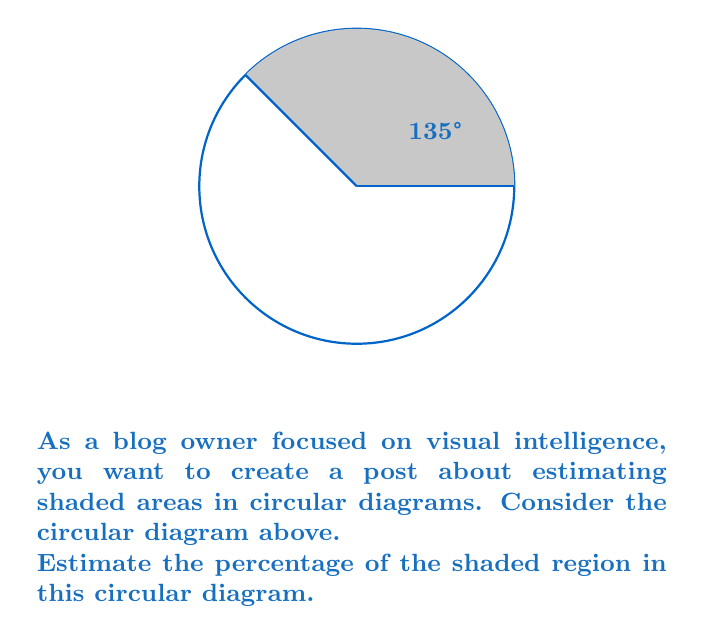Can you answer this question? To estimate the percentage of the shaded region, we need to follow these steps:

1) First, recognize that the shaded region is a sector of the circle with a central angle of 135°.

2) Recall that the area of a sector is proportional to its central angle. The full circle corresponds to 360°.

3) Set up the proportion:
   $$\frac{\text{Shaded Area}}{\text{Total Area}} = \frac{\text{Central Angle}}{360°}$$

4) Substitute the known angle:
   $$\frac{\text{Shaded Area}}{\text{Total Area}} = \frac{135°}{360°}$$

5) Simplify the fraction:
   $$\frac{\text{Shaded Area}}{\text{Total Area}} = \frac{3}{8} = 0.375$$

6) Convert to a percentage:
   $$0.375 \times 100\% = 37.5\%$$

Therefore, the shaded region represents approximately 37.5% of the total circular area.
Answer: 37.5% 